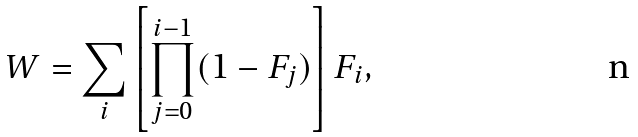<formula> <loc_0><loc_0><loc_500><loc_500>W = \sum _ { i } \left [ \prod _ { j = 0 } ^ { i - 1 } ( 1 - F _ { j } ) \right ] F _ { i } ,</formula> 